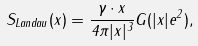<formula> <loc_0><loc_0><loc_500><loc_500>S _ { L a n d a u } ( x ) = \frac { \gamma \cdot x } { 4 \pi | x | ^ { 3 } } G ( | x | e ^ { 2 } ) ,</formula> 